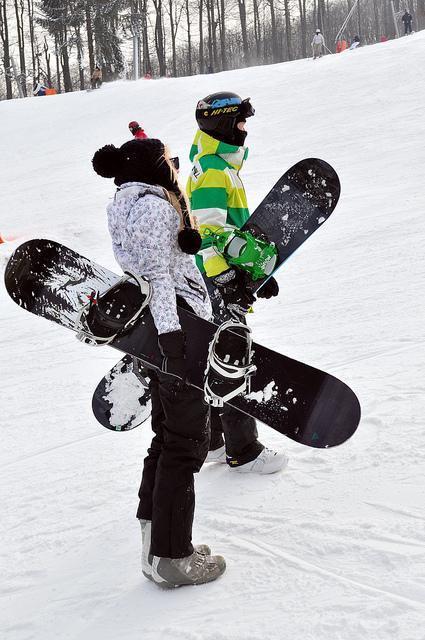How many people are in this picture?
Give a very brief answer. 2. How many snowboards are there?
Give a very brief answer. 2. How many people are there?
Give a very brief answer. 2. How many elephants do you see?
Give a very brief answer. 0. 